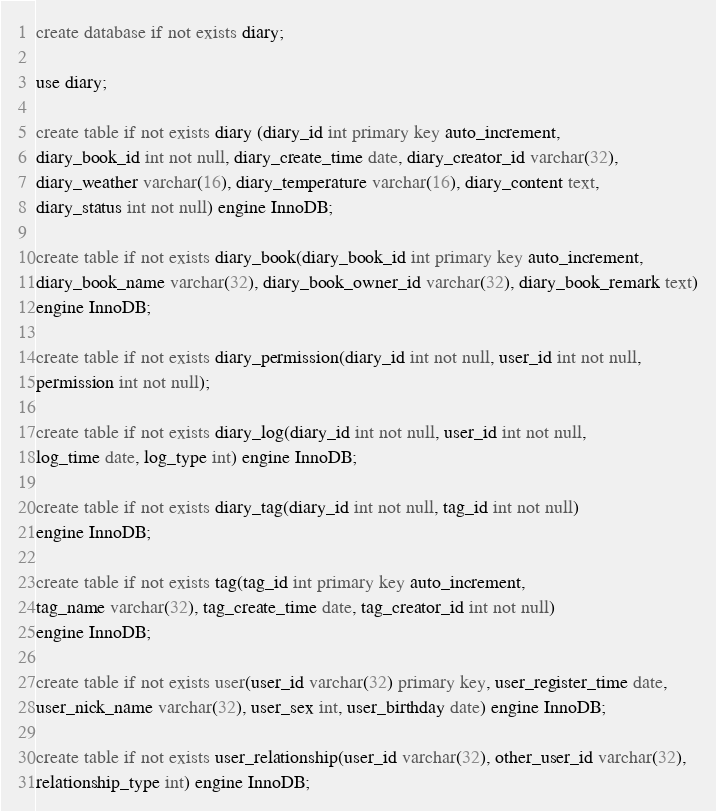<code> <loc_0><loc_0><loc_500><loc_500><_SQL_>create database if not exists diary;

use diary;

create table if not exists diary (diary_id int primary key auto_increment,
diary_book_id int not null, diary_create_time date, diary_creator_id varchar(32),
diary_weather varchar(16), diary_temperature varchar(16), diary_content text,
diary_status int not null) engine InnoDB;

create table if not exists diary_book(diary_book_id int primary key auto_increment,
diary_book_name varchar(32), diary_book_owner_id varchar(32), diary_book_remark text)
engine InnoDB;

create table if not exists diary_permission(diary_id int not null, user_id int not null,
permission int not null);

create table if not exists diary_log(diary_id int not null, user_id int not null,
log_time date, log_type int) engine InnoDB;

create table if not exists diary_tag(diary_id int not null, tag_id int not null)
engine InnoDB;

create table if not exists tag(tag_id int primary key auto_increment,
tag_name varchar(32), tag_create_time date, tag_creator_id int not null)
engine InnoDB;

create table if not exists user(user_id varchar(32) primary key, user_register_time date,
user_nick_name varchar(32), user_sex int, user_birthday date) engine InnoDB;

create table if not exists user_relationship(user_id varchar(32), other_user_id varchar(32),
relationship_type int) engine InnoDB;

</code> 